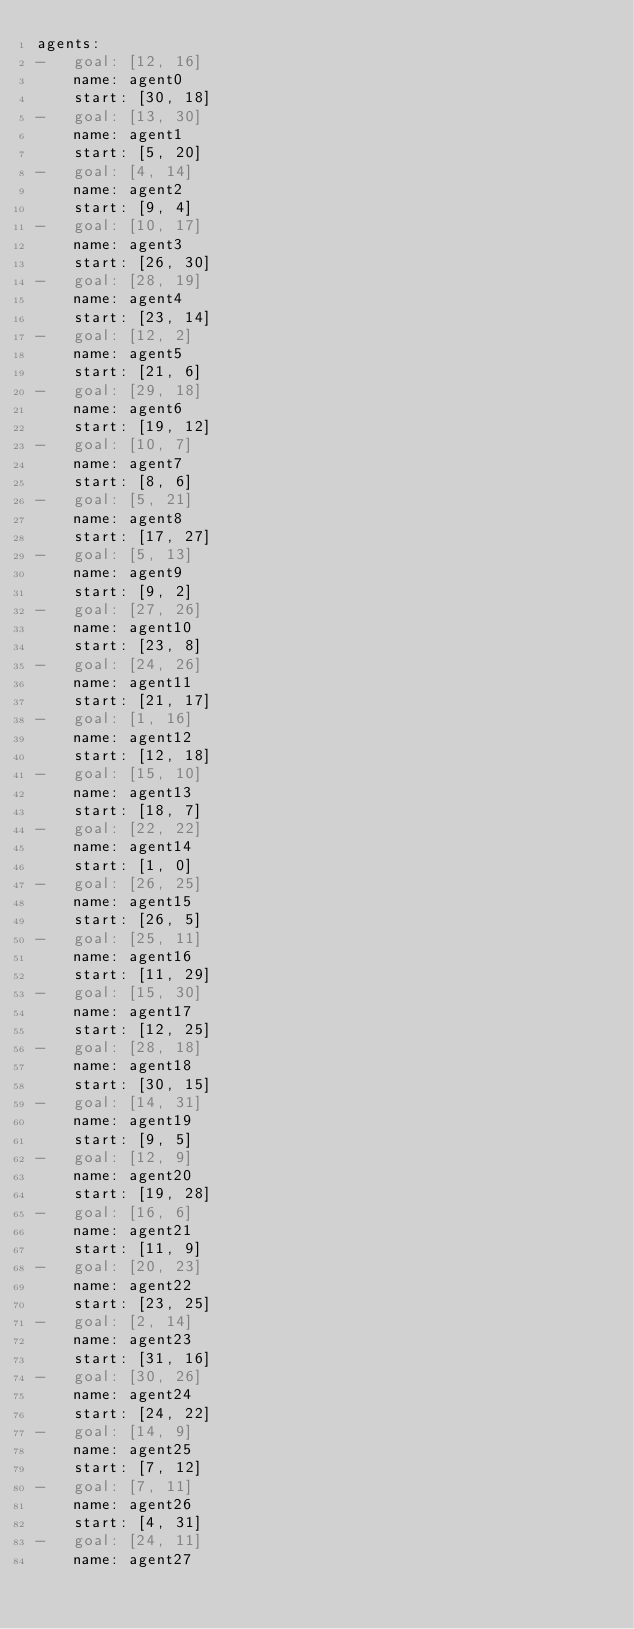Convert code to text. <code><loc_0><loc_0><loc_500><loc_500><_YAML_>agents:
-   goal: [12, 16]
    name: agent0
    start: [30, 18]
-   goal: [13, 30]
    name: agent1
    start: [5, 20]
-   goal: [4, 14]
    name: agent2
    start: [9, 4]
-   goal: [10, 17]
    name: agent3
    start: [26, 30]
-   goal: [28, 19]
    name: agent4
    start: [23, 14]
-   goal: [12, 2]
    name: agent5
    start: [21, 6]
-   goal: [29, 18]
    name: agent6
    start: [19, 12]
-   goal: [10, 7]
    name: agent7
    start: [8, 6]
-   goal: [5, 21]
    name: agent8
    start: [17, 27]
-   goal: [5, 13]
    name: agent9
    start: [9, 2]
-   goal: [27, 26]
    name: agent10
    start: [23, 8]
-   goal: [24, 26]
    name: agent11
    start: [21, 17]
-   goal: [1, 16]
    name: agent12
    start: [12, 18]
-   goal: [15, 10]
    name: agent13
    start: [18, 7]
-   goal: [22, 22]
    name: agent14
    start: [1, 0]
-   goal: [26, 25]
    name: agent15
    start: [26, 5]
-   goal: [25, 11]
    name: agent16
    start: [11, 29]
-   goal: [15, 30]
    name: agent17
    start: [12, 25]
-   goal: [28, 18]
    name: agent18
    start: [30, 15]
-   goal: [14, 31]
    name: agent19
    start: [9, 5]
-   goal: [12, 9]
    name: agent20
    start: [19, 28]
-   goal: [16, 6]
    name: agent21
    start: [11, 9]
-   goal: [20, 23]
    name: agent22
    start: [23, 25]
-   goal: [2, 14]
    name: agent23
    start: [31, 16]
-   goal: [30, 26]
    name: agent24
    start: [24, 22]
-   goal: [14, 9]
    name: agent25
    start: [7, 12]
-   goal: [7, 11]
    name: agent26
    start: [4, 31]
-   goal: [24, 11]
    name: agent27</code> 